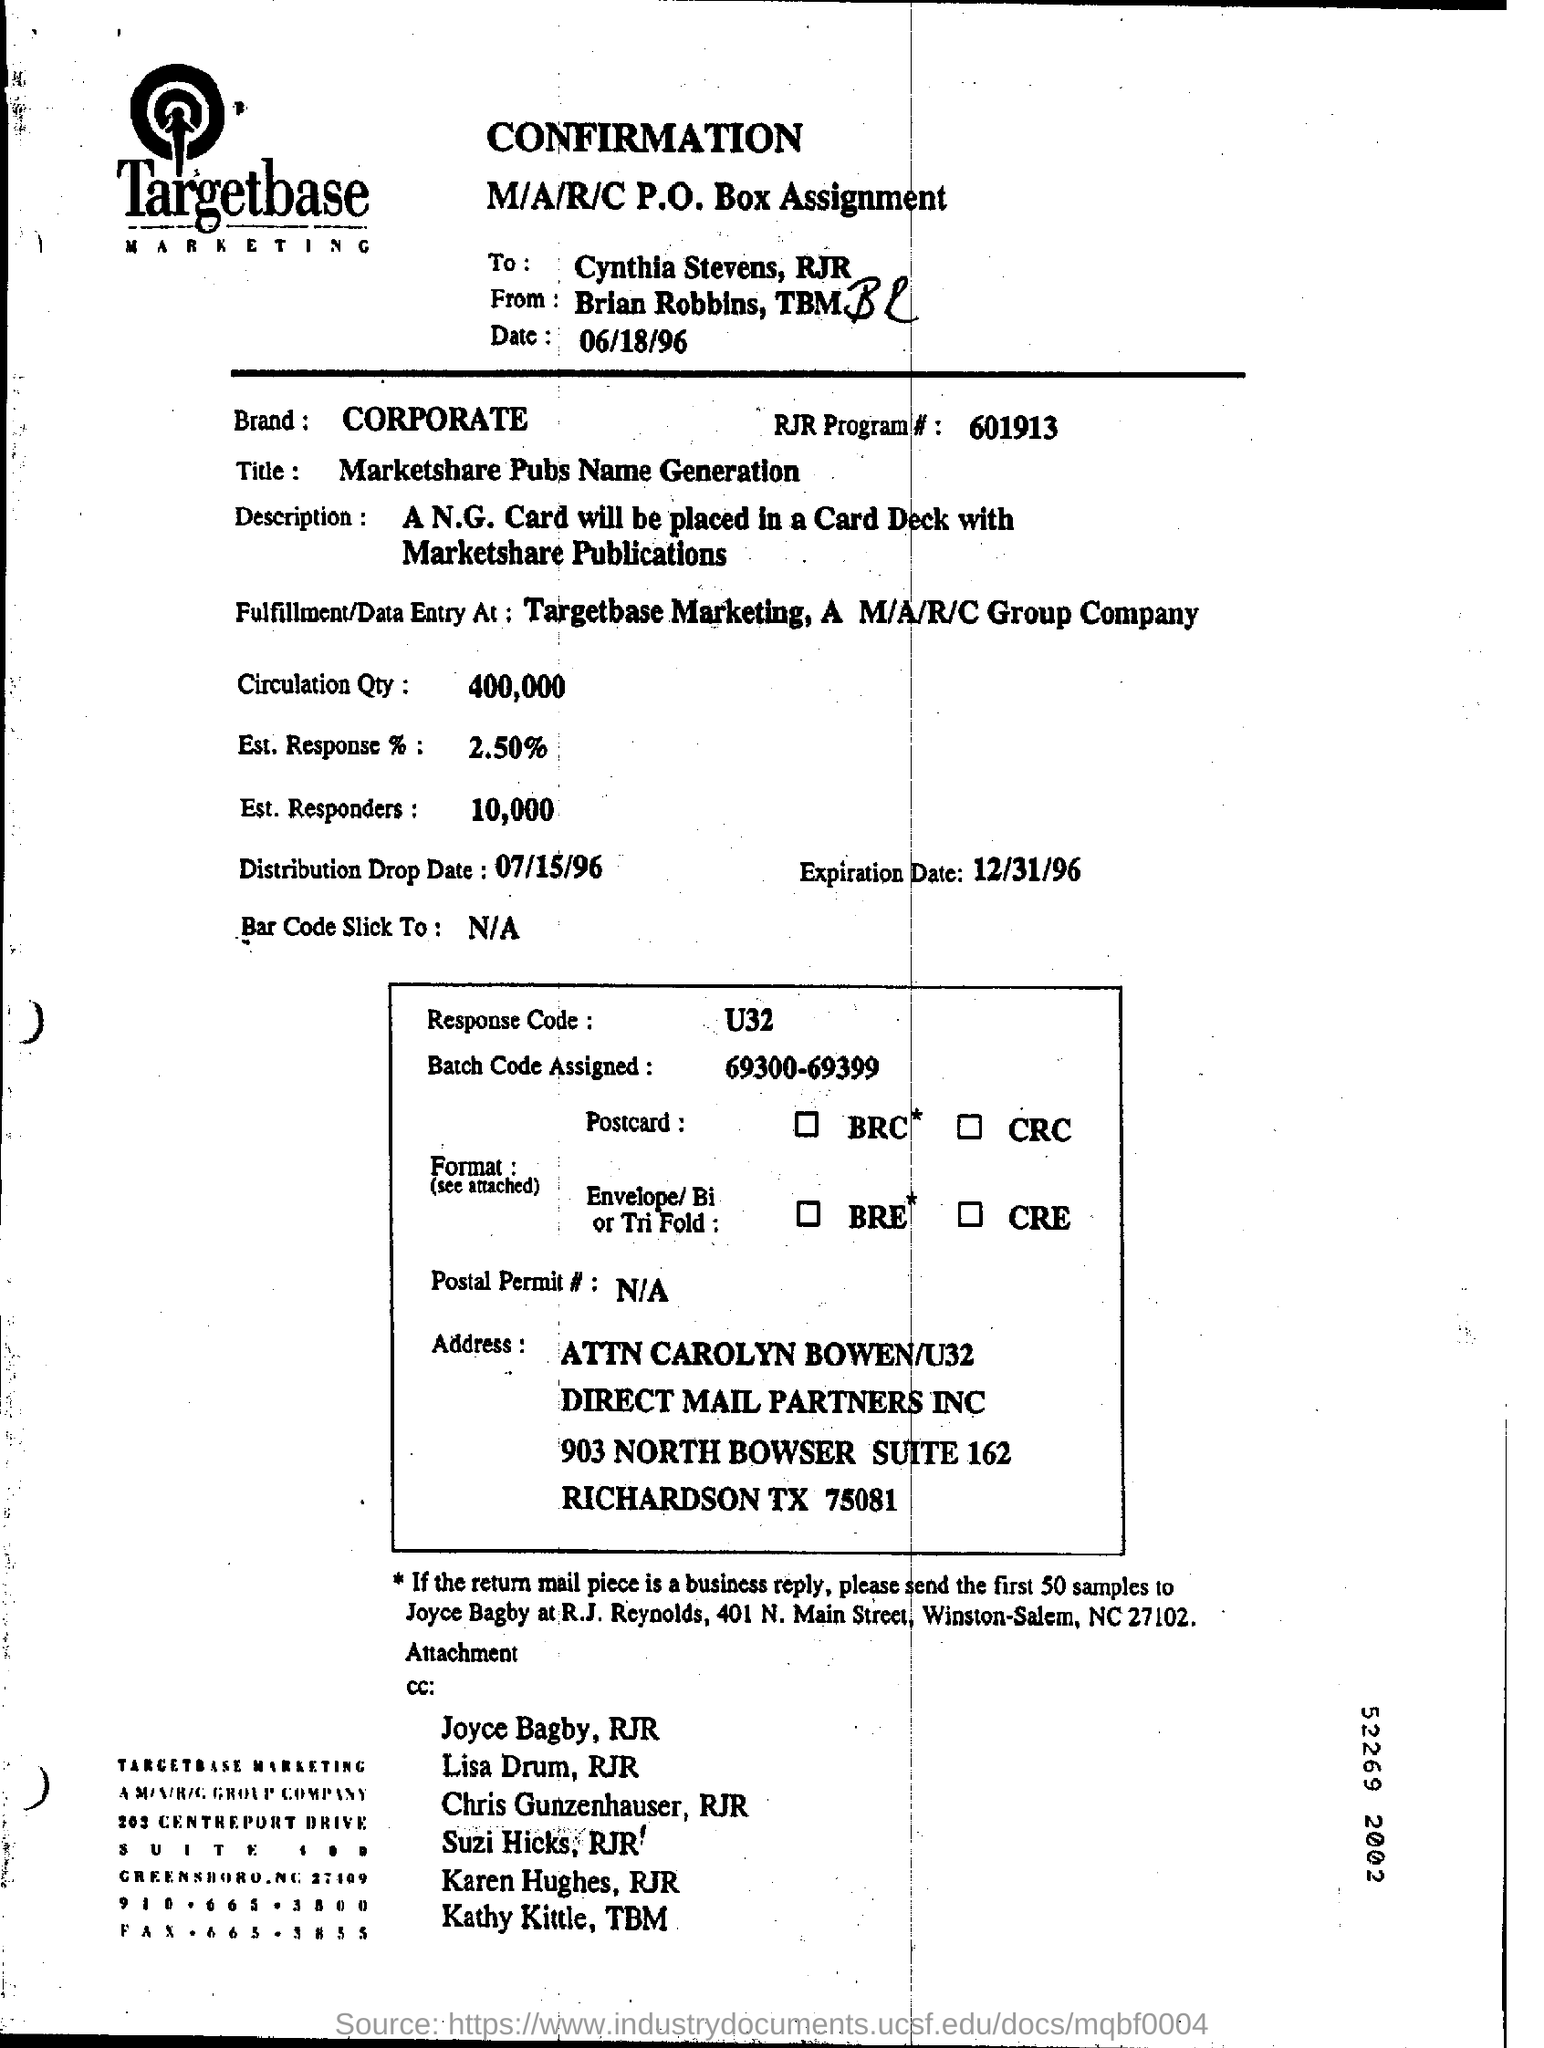What is the company name mentioned in the letterhead?
Make the answer very short. Targetbase MARKETING. What is the Expiration date mentioned in the document?
Provide a succinct answer. 12/31/96. What is the Circulation Qty as per the document?
Provide a short and direct response. 400,000. How many Est. Responders are there as per the document?
Provide a short and direct response. 10,000. What is the Est. Response %  as per the document?
Give a very brief answer. 2.50%. 